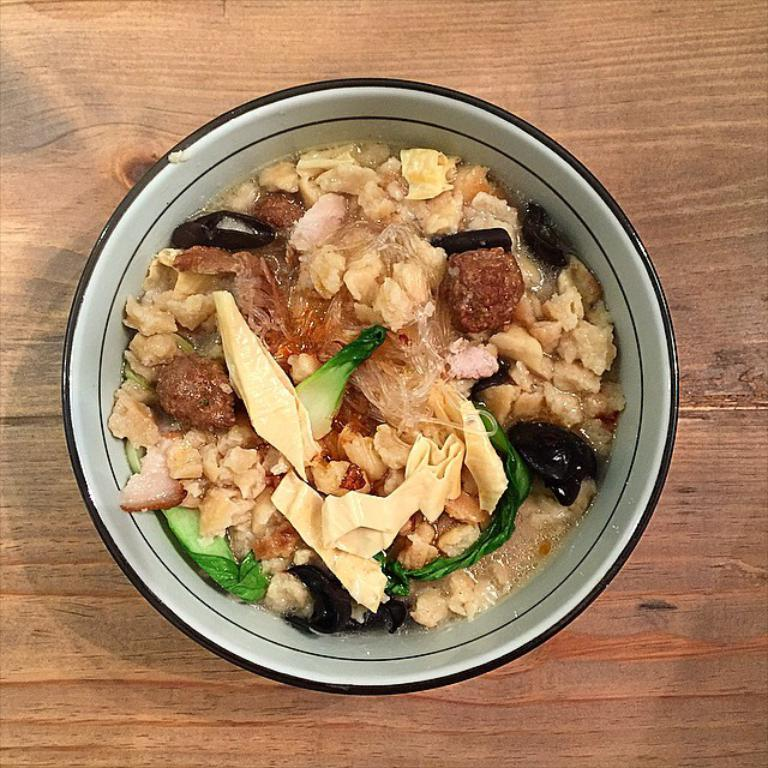What is in the bowl that is visible in the image? There is a food item in the bowl. Where is the bowl located in the image? The bowl is on a wooden floor. What type of apparel is the food item wearing in the image? There is no apparel present in the image, as the food item is not a person or an animal. 